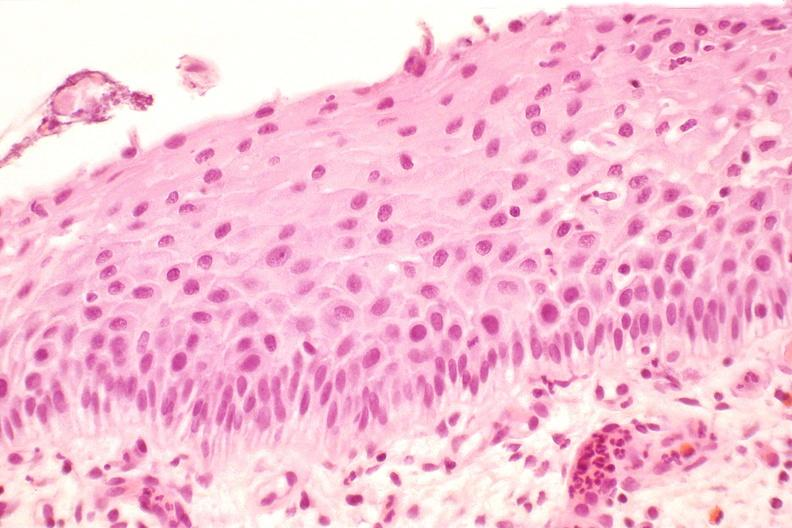s peritoneum present?
Answer the question using a single word or phrase. No 